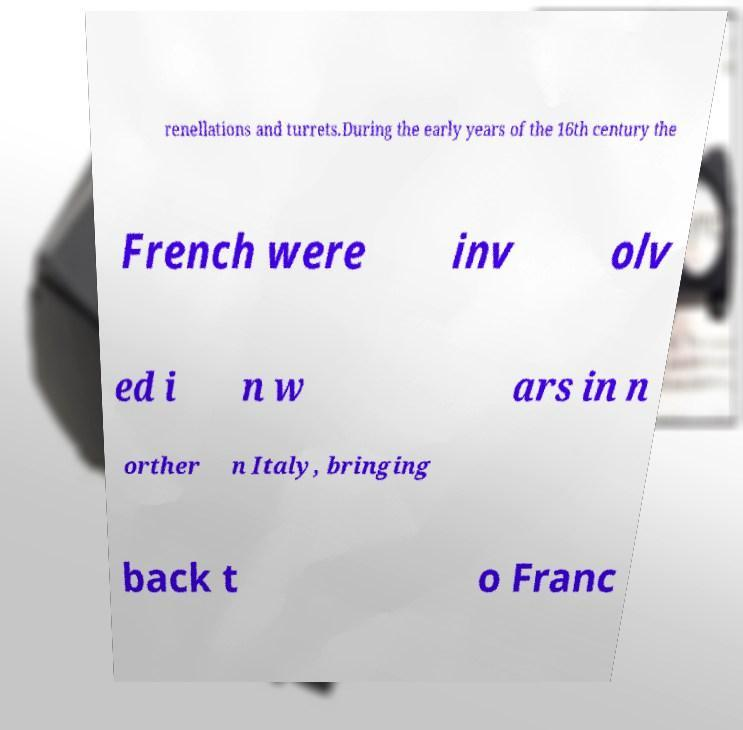There's text embedded in this image that I need extracted. Can you transcribe it verbatim? renellations and turrets.During the early years of the 16th century the French were inv olv ed i n w ars in n orther n Italy, bringing back t o Franc 